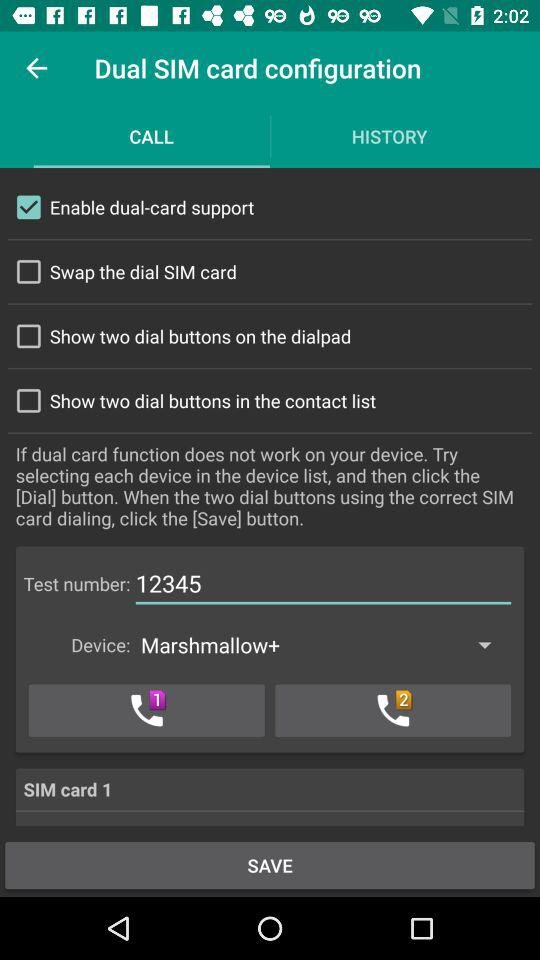What is the test number? The test number is 12345. 